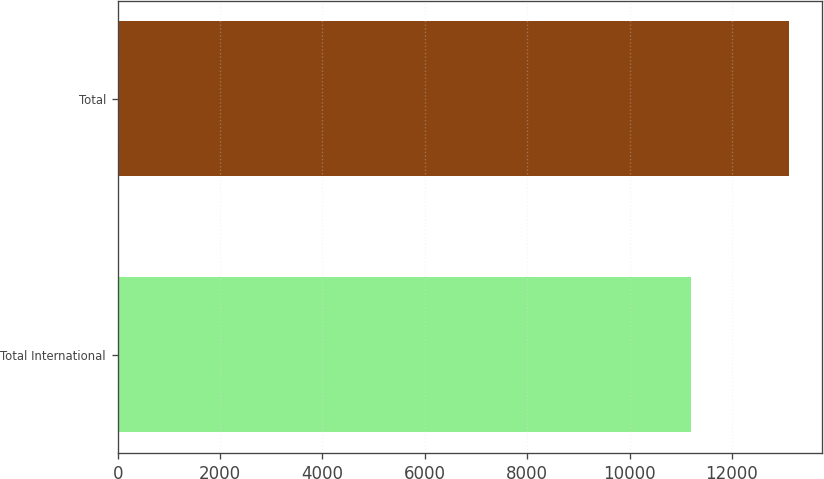Convert chart to OTSL. <chart><loc_0><loc_0><loc_500><loc_500><bar_chart><fcel>Total International<fcel>Total<nl><fcel>11193<fcel>13106<nl></chart> 